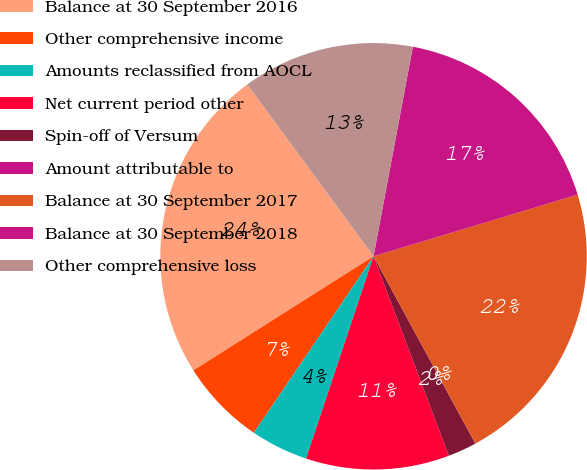<chart> <loc_0><loc_0><loc_500><loc_500><pie_chart><fcel>Balance at 30 September 2016<fcel>Other comprehensive income<fcel>Amounts reclassified from AOCL<fcel>Net current period other<fcel>Spin-off of Versum<fcel>Amount attributable to<fcel>Balance at 30 September 2017<fcel>Balance at 30 September 2018<fcel>Other comprehensive loss<nl><fcel>23.9%<fcel>6.53%<fcel>4.36%<fcel>10.87%<fcel>2.18%<fcel>0.01%<fcel>21.73%<fcel>17.38%<fcel>13.04%<nl></chart> 